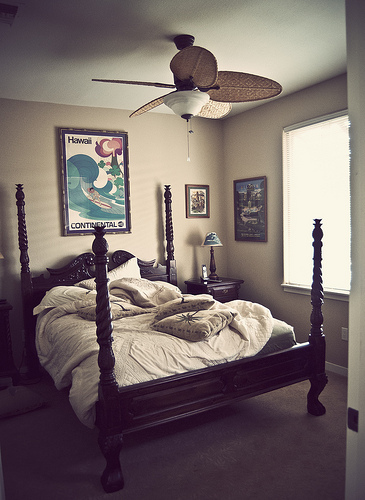<image>
Can you confirm if the light is to the right of the bed? Yes. From this viewpoint, the light is positioned to the right side relative to the bed. Is the fan behind the bed? No. The fan is not behind the bed. From this viewpoint, the fan appears to be positioned elsewhere in the scene. 